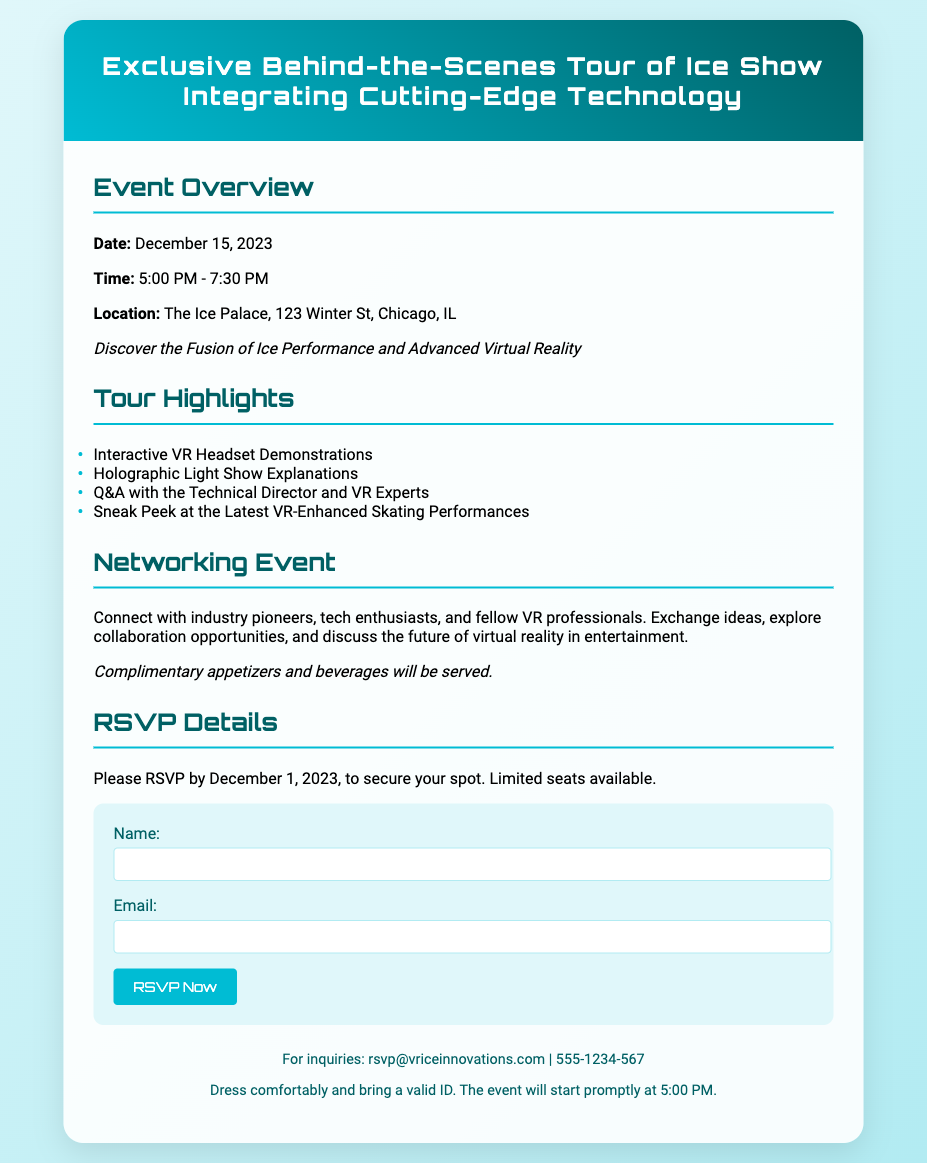What is the date of the event? The date of the event is explicitly mentioned in the event details section of the document as December 15, 2023.
Answer: December 15, 2023 What time does the event start? The start time of the event is provided in the same section alongside the date, indicating that it begins at 5:00 PM.
Answer: 5:00 PM Where is the event located? The location of the event is stated in the event details, which specifies The Ice Palace, 123 Winter St, Chicago, IL.
Answer: The Ice Palace, 123 Winter St, Chicago, IL What is one highlight of the tour? The tour highlights section lists several features, one of which is "Interactive VR Headset Demonstrations."
Answer: Interactive VR Headset Demonstrations By when should attendees RSVP? In the RSVP details, it clearly states the deadline for RSVPing as December 1, 2023.
Answer: December 1, 2023 How long is the event scheduled to last? The duration is indicated by the start and end time in the event details, lasting from 5:00 PM to 7:30 PM, totaling 2.5 hours.
Answer: 2.5 hours What will be served at the networking event? The networking section mentions that "Complimentary appetizers and beverages will be served."
Answer: Appetizers and beverages Who can attendees contact for inquiries? In the footer, a contact email address is provided for inquiries, which is rsvp@vriceinnovations.com.
Answer: rsvp@vriceinnovations.com 